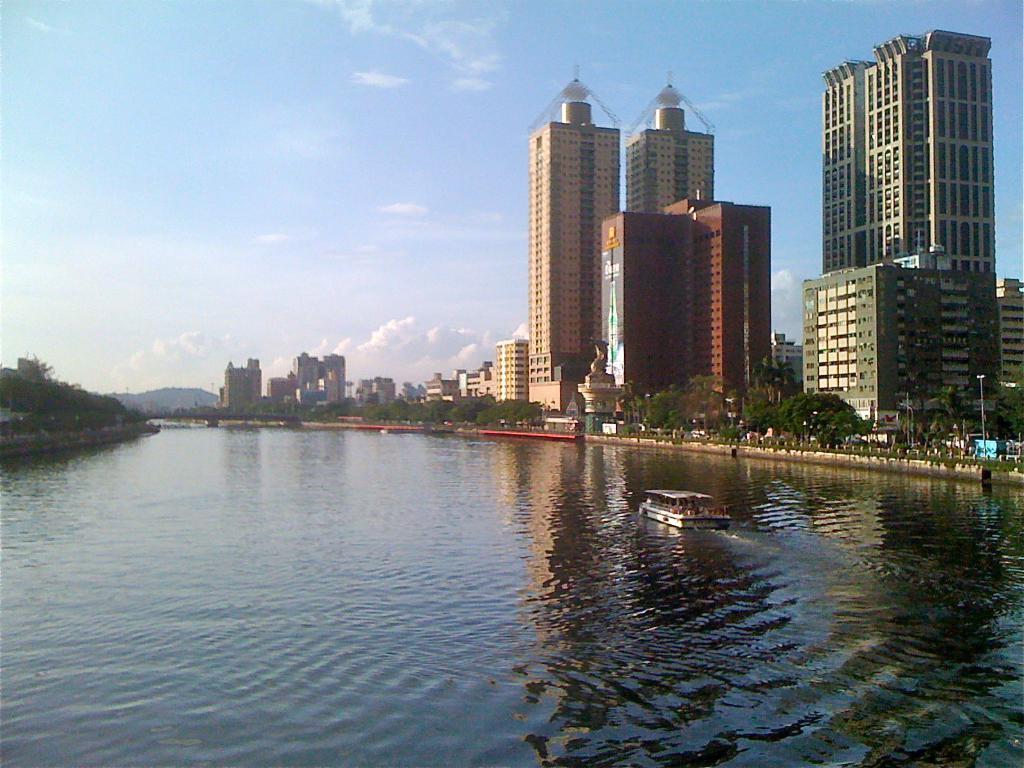Please provide a concise description of this image. In the foreground of the picture there is a river, in the river there is a boat. In the center of the picture towards right there are skyscrapers, buildings, poles, trees, railing and other objects. In the center of the picture towards left there are buildings, trees and hill. Sky is sunny. 